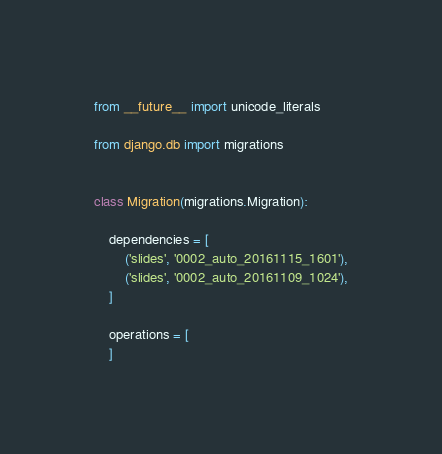Convert code to text. <code><loc_0><loc_0><loc_500><loc_500><_Python_>from __future__ import unicode_literals

from django.db import migrations


class Migration(migrations.Migration):

    dependencies = [
        ('slides', '0002_auto_20161115_1601'),
        ('slides', '0002_auto_20161109_1024'),
    ]

    operations = [
    ]
</code> 